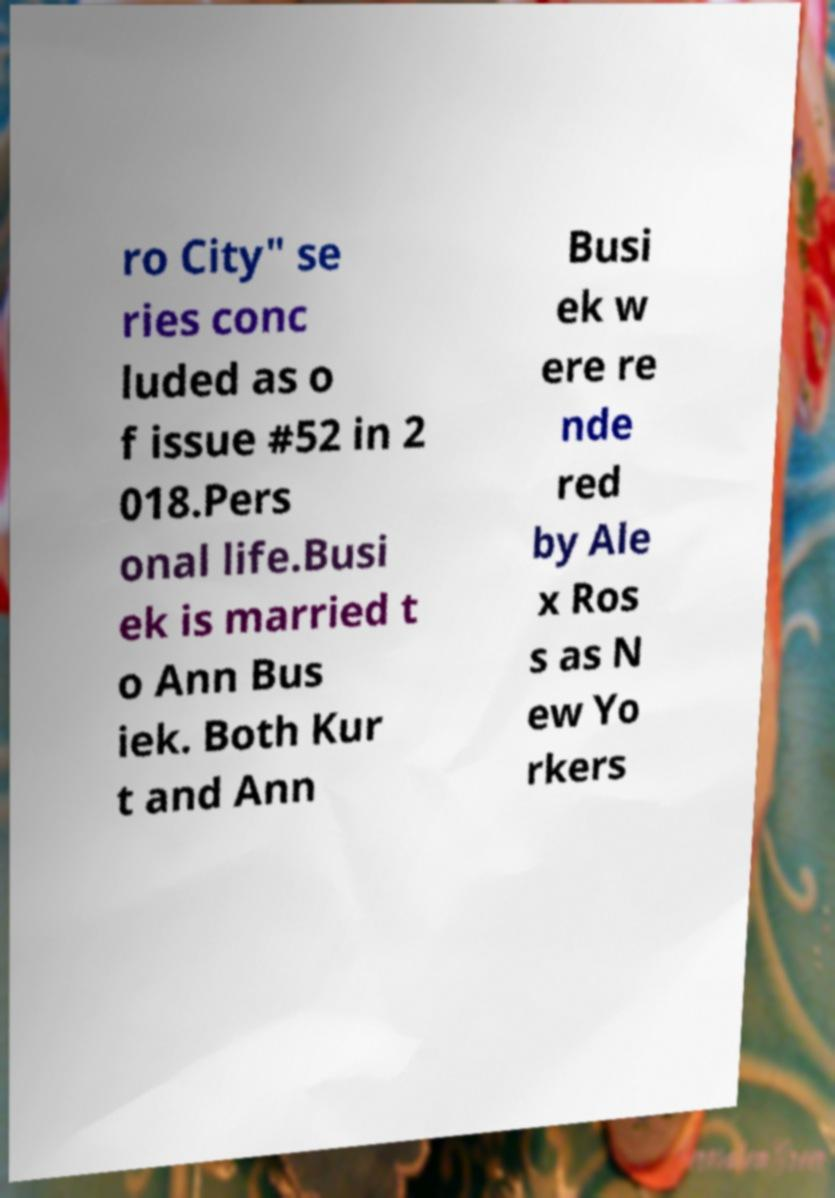I need the written content from this picture converted into text. Can you do that? ro City" se ries conc luded as o f issue #52 in 2 018.Pers onal life.Busi ek is married t o Ann Bus iek. Both Kur t and Ann Busi ek w ere re nde red by Ale x Ros s as N ew Yo rkers 